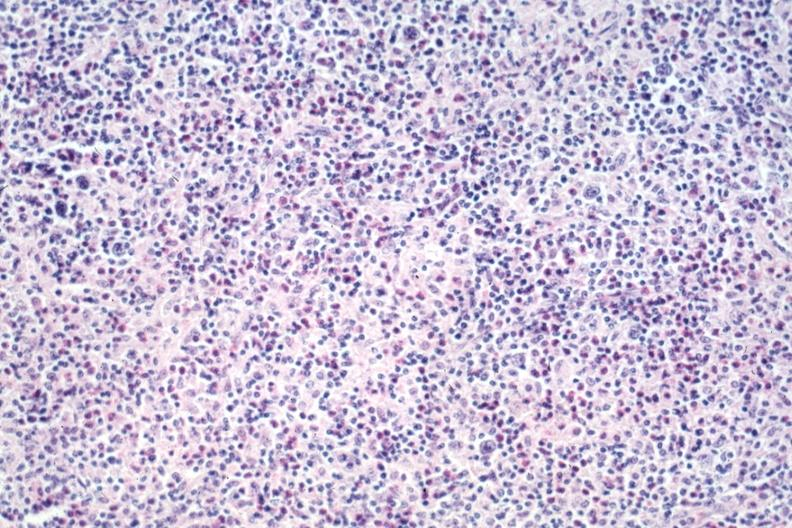what does this image show?
Answer the question using a single word or phrase. Typical lesion rich in eosinophils source 